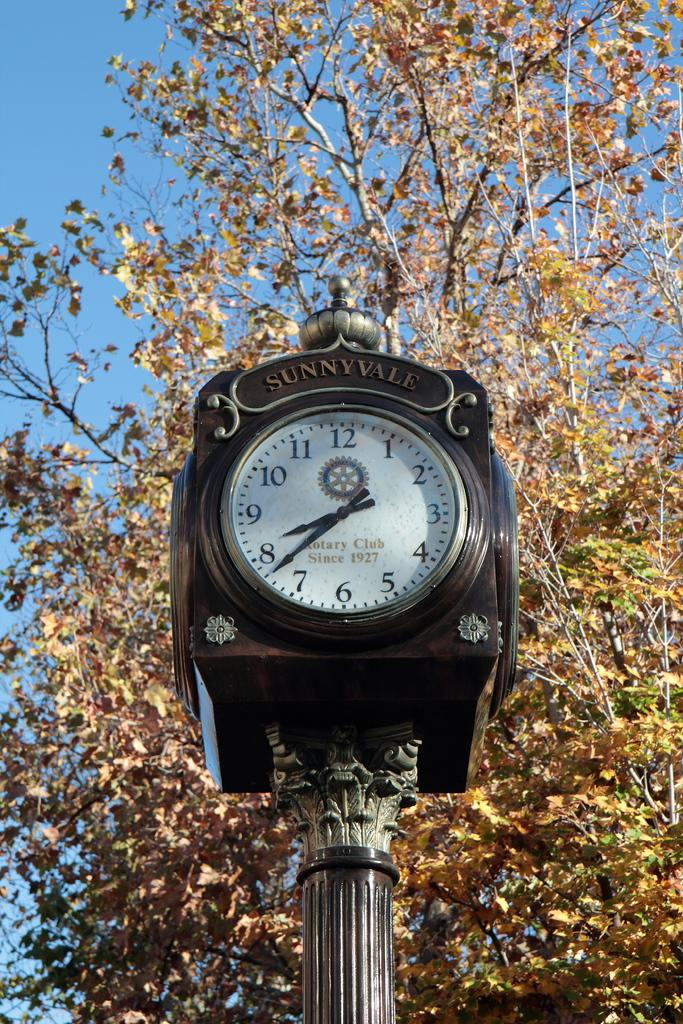<image>
Present a compact description of the photo's key features. A black clock labelled Sunnyville on a pole. 